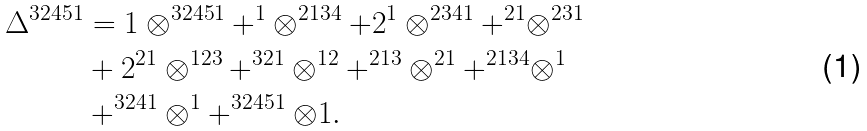Convert formula to latex. <formula><loc_0><loc_0><loc_500><loc_500>\Delta ^ { 3 2 4 5 1 } & = 1 \otimes ^ { 3 2 4 5 1 } + ^ { 1 } \otimes ^ { 2 1 3 4 } + 2 ^ { 1 } \otimes ^ { 2 3 4 1 } + ^ { 2 1 } \otimes ^ { 2 3 1 } \\ & + 2 ^ { 2 1 } \otimes ^ { 1 2 3 } + ^ { 3 2 1 } \otimes ^ { 1 2 } + ^ { 2 1 3 } \otimes ^ { 2 1 } + ^ { 2 1 3 4 } \otimes ^ { 1 } \\ & + ^ { 3 2 4 1 } \otimes ^ { 1 } + ^ { 3 2 4 5 1 } \otimes 1 .</formula> 